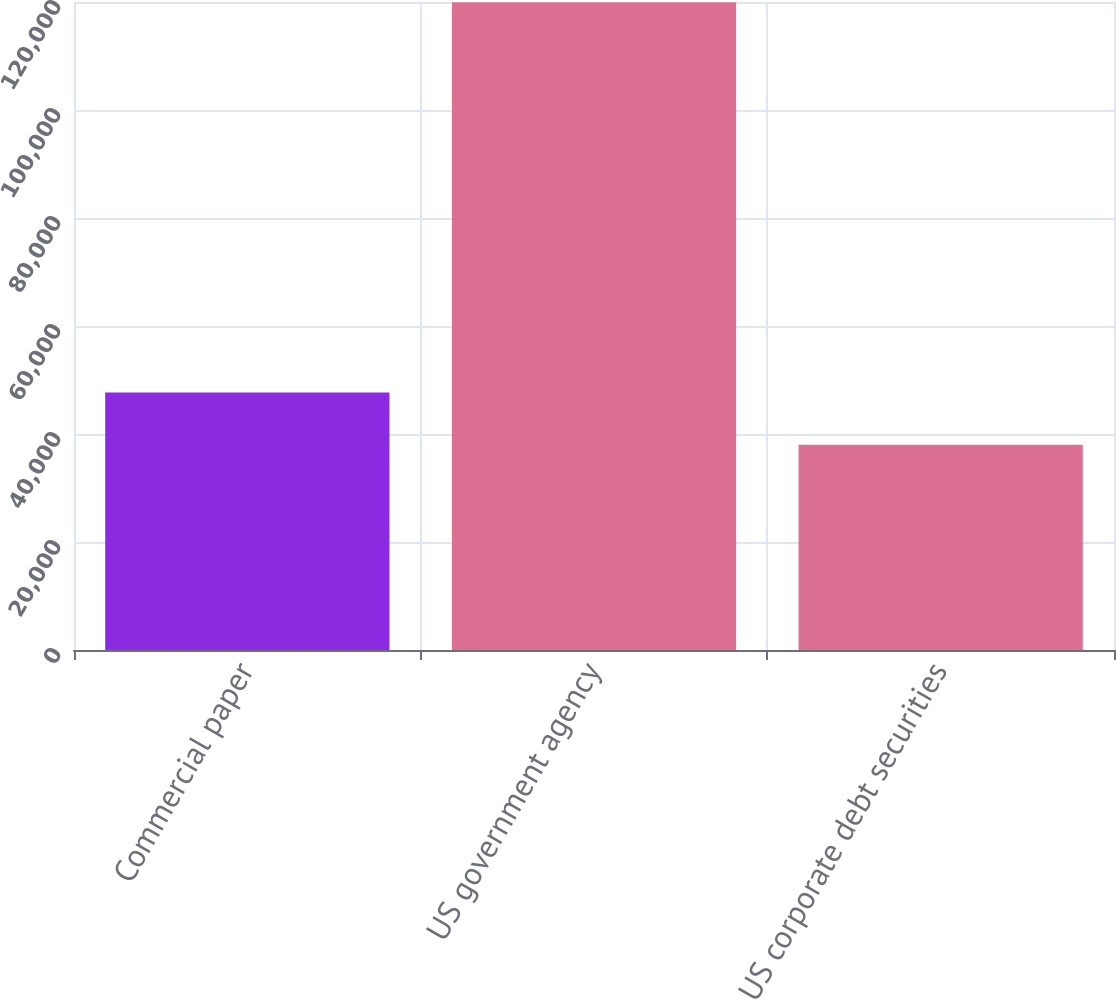<chart> <loc_0><loc_0><loc_500><loc_500><bar_chart><fcel>Commercial paper<fcel>US government agency<fcel>US corporate debt securities<nl><fcel>47669<fcel>119961<fcel>37998<nl></chart> 